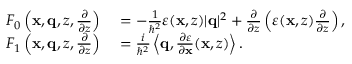Convert formula to latex. <formula><loc_0><loc_0><loc_500><loc_500>\begin{array} { r l } { F _ { 0 } \left ( x , q , z , \frac { \partial } { \partial z } \right ) } & = - \frac { 1 } { \hbar { ^ } { 2 } } \varepsilon ( x , z ) | q | ^ { 2 } + \frac { \partial } { \partial z } \left ( \varepsilon ( x , z ) \frac { \partial } { \partial z } \right ) , } \\ { F _ { 1 } \left ( x , q , z , \frac { \partial } { \partial z } \right ) } & = \frac { i } { \hbar { ^ } { 2 } } \left \langle q , \frac { \partial \varepsilon } { \partial x } ( x , z ) \right \rangle . } \end{array}</formula> 